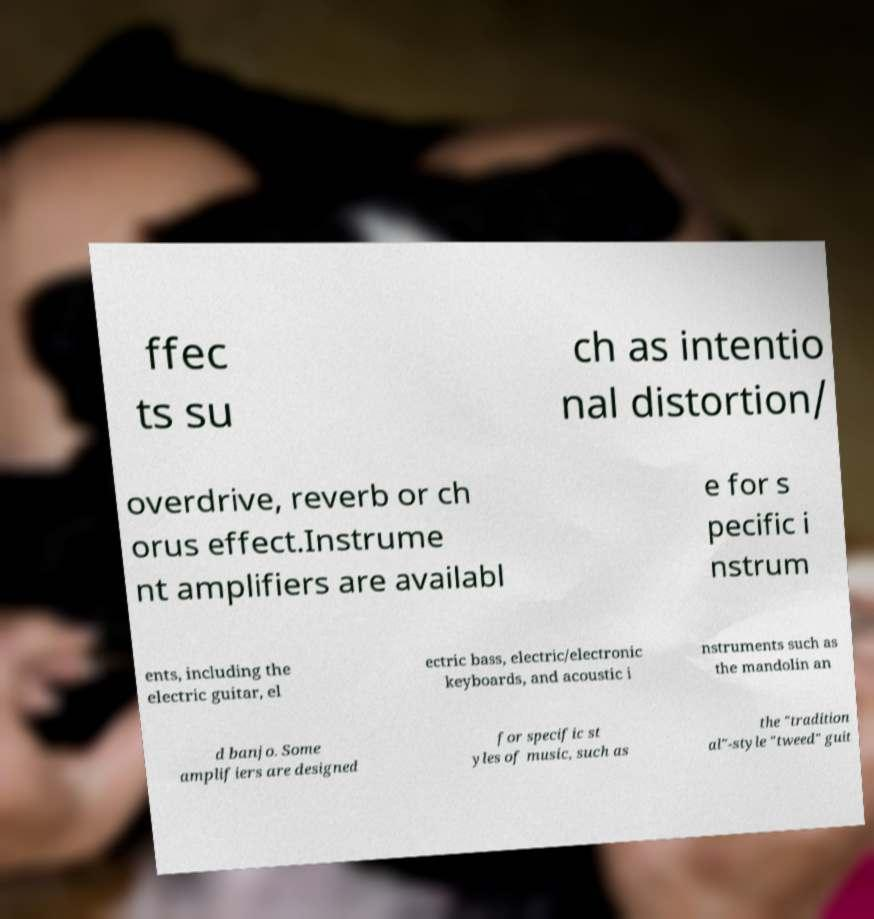For documentation purposes, I need the text within this image transcribed. Could you provide that? ffec ts su ch as intentio nal distortion/ overdrive, reverb or ch orus effect.Instrume nt amplifiers are availabl e for s pecific i nstrum ents, including the electric guitar, el ectric bass, electric/electronic keyboards, and acoustic i nstruments such as the mandolin an d banjo. Some amplifiers are designed for specific st yles of music, such as the "tradition al"-style "tweed" guit 